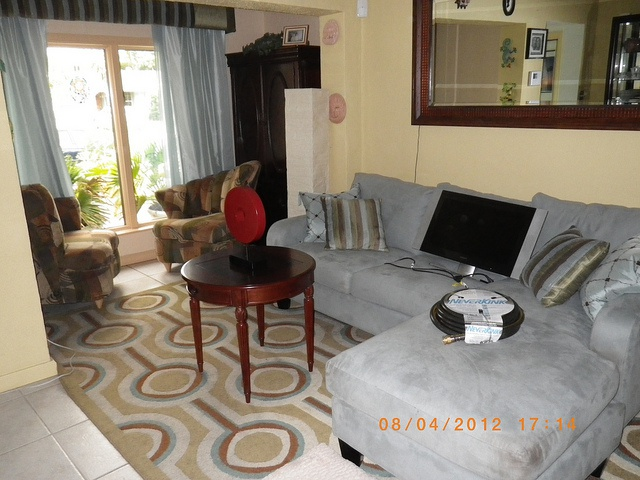Describe the objects in this image and their specific colors. I can see couch in black, darkgray, gray, and lightgray tones, tv in black, gray, and lightgray tones, chair in black, maroon, and gray tones, and chair in black, maroon, and gray tones in this image. 